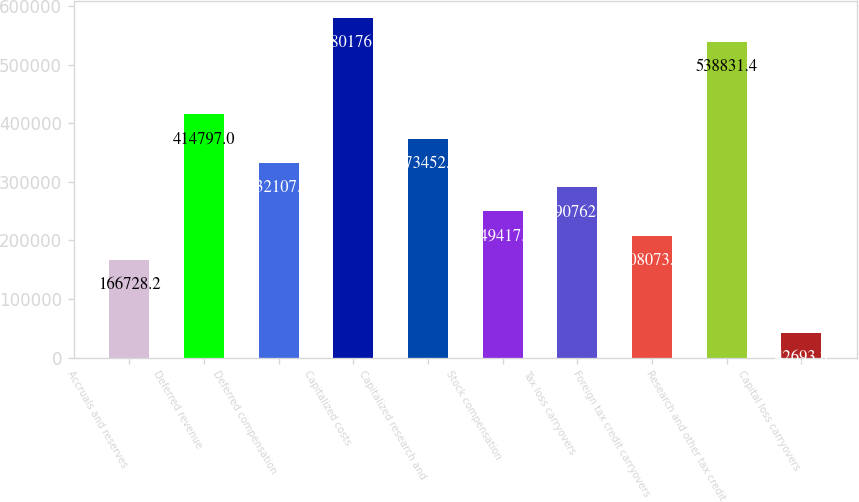<chart> <loc_0><loc_0><loc_500><loc_500><bar_chart><fcel>Accruals and reserves<fcel>Deferred revenue<fcel>Deferred compensation<fcel>Capitalized costs<fcel>Capitalized research and<fcel>Stock compensation<fcel>Tax loss carryovers<fcel>Foreign tax credit carryovers<fcel>Research and other tax credit<fcel>Capital loss carryovers<nl><fcel>166728<fcel>414797<fcel>332107<fcel>580176<fcel>373452<fcel>249418<fcel>290763<fcel>208073<fcel>538831<fcel>42693.8<nl></chart> 